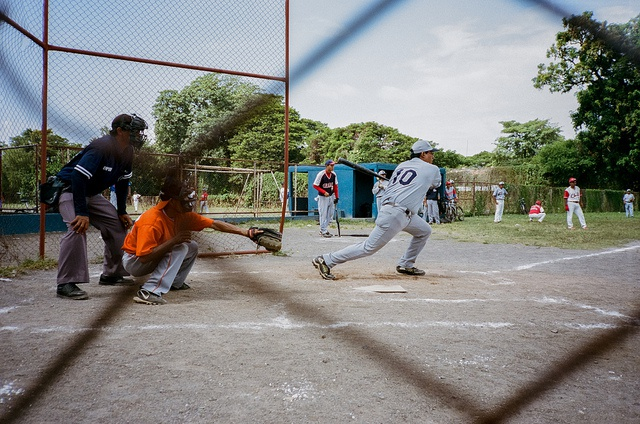Describe the objects in this image and their specific colors. I can see people in gray, black, and maroon tones, people in gray, black, maroon, and red tones, people in gray and darkgray tones, people in gray, darkgray, and black tones, and people in gray, darkgray, and lightgray tones in this image. 